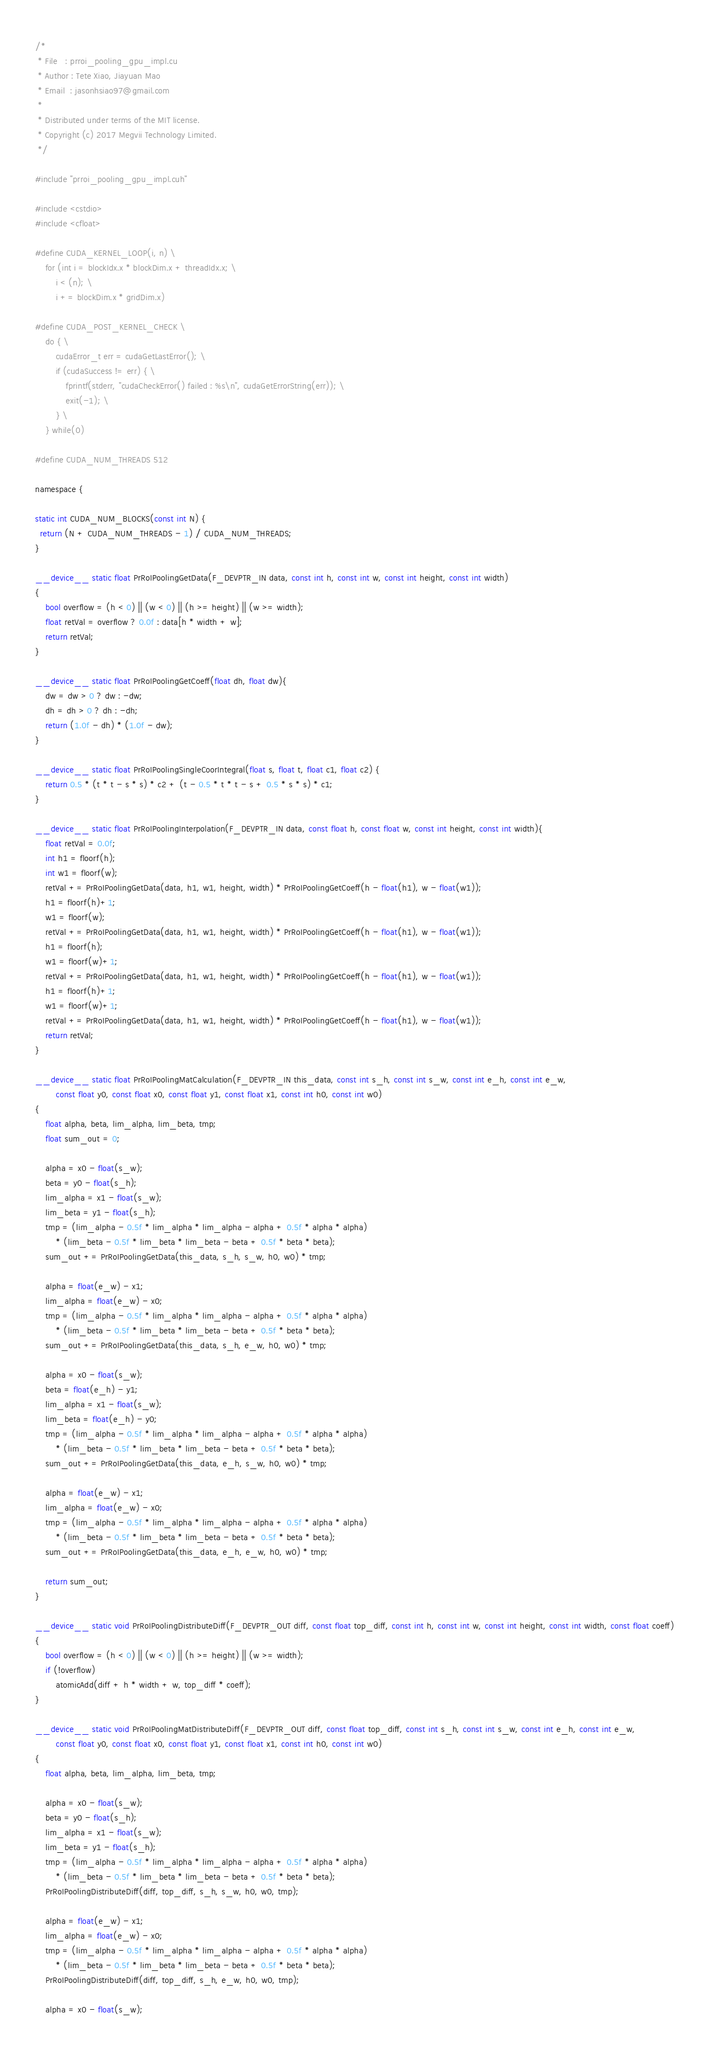Convert code to text. <code><loc_0><loc_0><loc_500><loc_500><_Cuda_>/*
 * File   : prroi_pooling_gpu_impl.cu
 * Author : Tete Xiao, Jiayuan Mao
 * Email  : jasonhsiao97@gmail.com
 *
 * Distributed under terms of the MIT license.
 * Copyright (c) 2017 Megvii Technology Limited.
 */

#include "prroi_pooling_gpu_impl.cuh"

#include <cstdio>
#include <cfloat>

#define CUDA_KERNEL_LOOP(i, n) \
    for (int i = blockIdx.x * blockDim.x + threadIdx.x; \
        i < (n); \
        i += blockDim.x * gridDim.x)

#define CUDA_POST_KERNEL_CHECK \
    do { \
        cudaError_t err = cudaGetLastError(); \
        if (cudaSuccess != err) { \
            fprintf(stderr, "cudaCheckError() failed : %s\n", cudaGetErrorString(err)); \
            exit(-1); \
        } \
    } while(0)

#define CUDA_NUM_THREADS 512

namespace {

static int CUDA_NUM_BLOCKS(const int N) {
  return (N + CUDA_NUM_THREADS - 1) / CUDA_NUM_THREADS;
}

__device__ static float PrRoIPoolingGetData(F_DEVPTR_IN data, const int h, const int w, const int height, const int width)
{
    bool overflow = (h < 0) || (w < 0) || (h >= height) || (w >= width);
    float retVal = overflow ? 0.0f : data[h * width + w];
    return retVal;
}

__device__ static float PrRoIPoolingGetCoeff(float dh, float dw){
    dw = dw > 0 ? dw : -dw;
    dh = dh > 0 ? dh : -dh;
    return (1.0f - dh) * (1.0f - dw);
}

__device__ static float PrRoIPoolingSingleCoorIntegral(float s, float t, float c1, float c2) {
    return 0.5 * (t * t - s * s) * c2 + (t - 0.5 * t * t - s + 0.5 * s * s) * c1;
}

__device__ static float PrRoIPoolingInterpolation(F_DEVPTR_IN data, const float h, const float w, const int height, const int width){
    float retVal = 0.0f;
    int h1 = floorf(h);
    int w1 = floorf(w);
    retVal += PrRoIPoolingGetData(data, h1, w1, height, width) * PrRoIPoolingGetCoeff(h - float(h1), w - float(w1));
    h1 = floorf(h)+1;
    w1 = floorf(w);
    retVal += PrRoIPoolingGetData(data, h1, w1, height, width) * PrRoIPoolingGetCoeff(h - float(h1), w - float(w1));
    h1 = floorf(h);
    w1 = floorf(w)+1;
    retVal += PrRoIPoolingGetData(data, h1, w1, height, width) * PrRoIPoolingGetCoeff(h - float(h1), w - float(w1));
    h1 = floorf(h)+1;
    w1 = floorf(w)+1;
    retVal += PrRoIPoolingGetData(data, h1, w1, height, width) * PrRoIPoolingGetCoeff(h - float(h1), w - float(w1));
    return retVal;
}

__device__ static float PrRoIPoolingMatCalculation(F_DEVPTR_IN this_data, const int s_h, const int s_w, const int e_h, const int e_w,
        const float y0, const float x0, const float y1, const float x1, const int h0, const int w0)
{
    float alpha, beta, lim_alpha, lim_beta, tmp;
    float sum_out = 0;

    alpha = x0 - float(s_w);
    beta = y0 - float(s_h);
    lim_alpha = x1 - float(s_w);
    lim_beta = y1 - float(s_h);
    tmp = (lim_alpha - 0.5f * lim_alpha * lim_alpha - alpha + 0.5f * alpha * alpha)
        * (lim_beta - 0.5f * lim_beta * lim_beta - beta + 0.5f * beta * beta);
    sum_out += PrRoIPoolingGetData(this_data, s_h, s_w, h0, w0) * tmp;

    alpha = float(e_w) - x1;
    lim_alpha = float(e_w) - x0;
    tmp = (lim_alpha - 0.5f * lim_alpha * lim_alpha - alpha + 0.5f * alpha * alpha)
        * (lim_beta - 0.5f * lim_beta * lim_beta - beta + 0.5f * beta * beta);
    sum_out += PrRoIPoolingGetData(this_data, s_h, e_w, h0, w0) * tmp;

    alpha = x0 - float(s_w);
    beta = float(e_h) - y1;
    lim_alpha = x1 - float(s_w);
    lim_beta = float(e_h) - y0;
    tmp = (lim_alpha - 0.5f * lim_alpha * lim_alpha - alpha + 0.5f * alpha * alpha)
        * (lim_beta - 0.5f * lim_beta * lim_beta - beta + 0.5f * beta * beta);
    sum_out += PrRoIPoolingGetData(this_data, e_h, s_w, h0, w0) * tmp;

    alpha = float(e_w) - x1;
    lim_alpha = float(e_w) - x0;
    tmp = (lim_alpha - 0.5f * lim_alpha * lim_alpha - alpha + 0.5f * alpha * alpha)
        * (lim_beta - 0.5f * lim_beta * lim_beta - beta + 0.5f * beta * beta);
    sum_out += PrRoIPoolingGetData(this_data, e_h, e_w, h0, w0) * tmp;

    return sum_out;
}

__device__ static void PrRoIPoolingDistributeDiff(F_DEVPTR_OUT diff, const float top_diff, const int h, const int w, const int height, const int width, const float coeff)
{
    bool overflow = (h < 0) || (w < 0) || (h >= height) || (w >= width);
    if (!overflow)
        atomicAdd(diff + h * width + w, top_diff * coeff);
}

__device__ static void PrRoIPoolingMatDistributeDiff(F_DEVPTR_OUT diff, const float top_diff, const int s_h, const int s_w, const int e_h, const int e_w,
        const float y0, const float x0, const float y1, const float x1, const int h0, const int w0)
{
    float alpha, beta, lim_alpha, lim_beta, tmp;

    alpha = x0 - float(s_w);
    beta = y0 - float(s_h);
    lim_alpha = x1 - float(s_w);
    lim_beta = y1 - float(s_h);
    tmp = (lim_alpha - 0.5f * lim_alpha * lim_alpha - alpha + 0.5f * alpha * alpha)
        * (lim_beta - 0.5f * lim_beta * lim_beta - beta + 0.5f * beta * beta);
    PrRoIPoolingDistributeDiff(diff, top_diff, s_h, s_w, h0, w0, tmp);

    alpha = float(e_w) - x1;
    lim_alpha = float(e_w) - x0;
    tmp = (lim_alpha - 0.5f * lim_alpha * lim_alpha - alpha + 0.5f * alpha * alpha)
        * (lim_beta - 0.5f * lim_beta * lim_beta - beta + 0.5f * beta * beta);
    PrRoIPoolingDistributeDiff(diff, top_diff, s_h, e_w, h0, w0, tmp);

    alpha = x0 - float(s_w);</code> 